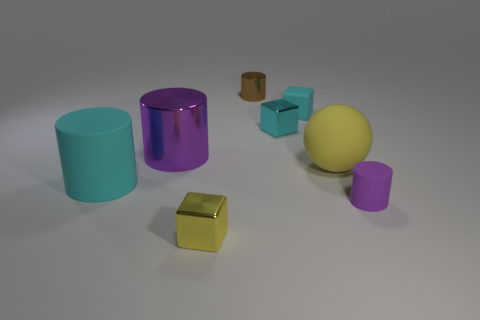How many big cylinders are behind the large ball?
Your answer should be compact. 1. How many things are either small metal objects that are in front of the matte cube or tiny yellow shiny things?
Your answer should be compact. 2. Are there more cylinders left of the large purple metal object than tiny objects that are in front of the purple matte cylinder?
Provide a succinct answer. No. What is the size of the metallic thing that is the same color as the small rubber cube?
Your answer should be compact. Small. Is the size of the yellow rubber object the same as the cyan object that is in front of the large purple shiny thing?
Offer a terse response. Yes. What number of cubes are either big objects or large yellow matte things?
Give a very brief answer. 0. The cyan cylinder that is the same material as the large sphere is what size?
Provide a succinct answer. Large. There is a metal cylinder that is on the left side of the small brown cylinder; is it the same size as the rubber cylinder to the right of the tiny metal cylinder?
Your answer should be very brief. No. What number of objects are tiny purple metal cylinders or brown objects?
Keep it short and to the point. 1. What is the shape of the large metal thing?
Give a very brief answer. Cylinder. 